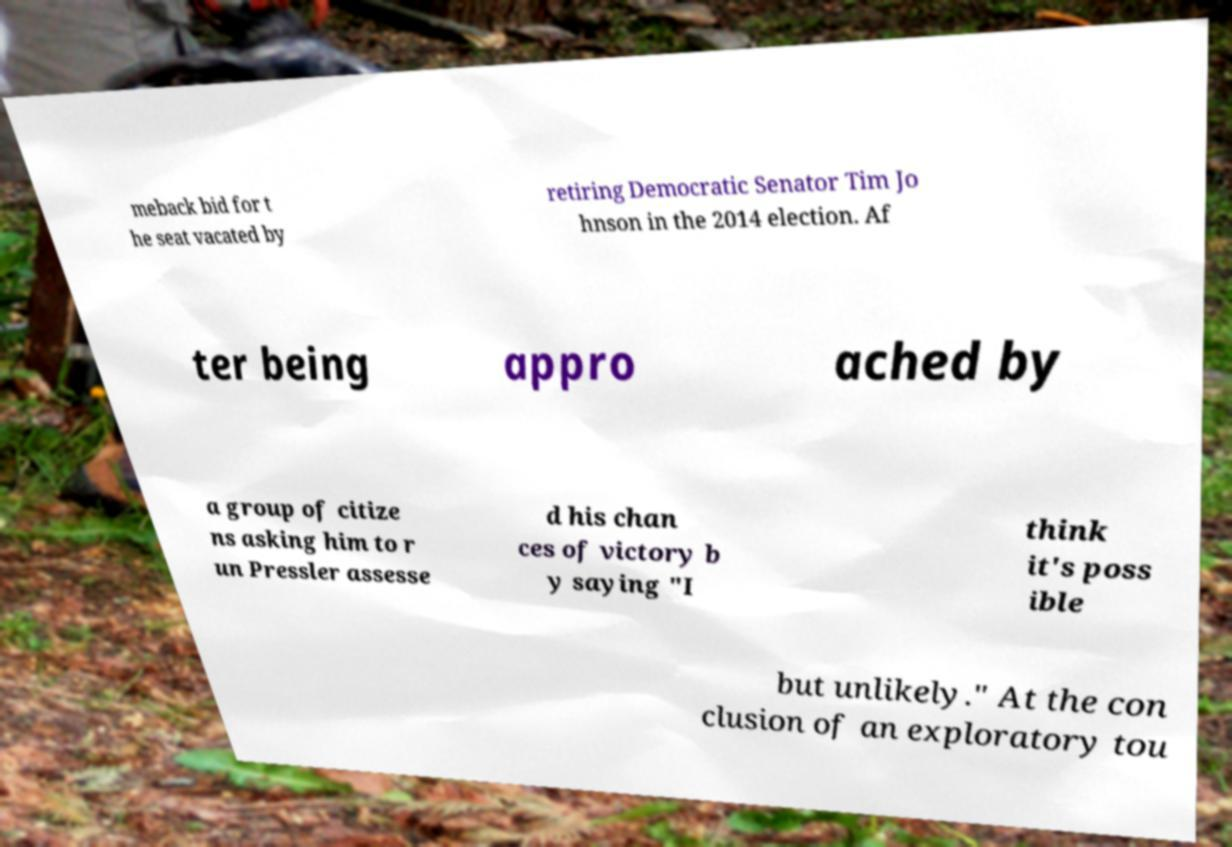Can you read and provide the text displayed in the image?This photo seems to have some interesting text. Can you extract and type it out for me? meback bid for t he seat vacated by retiring Democratic Senator Tim Jo hnson in the 2014 election. Af ter being appro ached by a group of citize ns asking him to r un Pressler assesse d his chan ces of victory b y saying "I think it's poss ible but unlikely." At the con clusion of an exploratory tou 